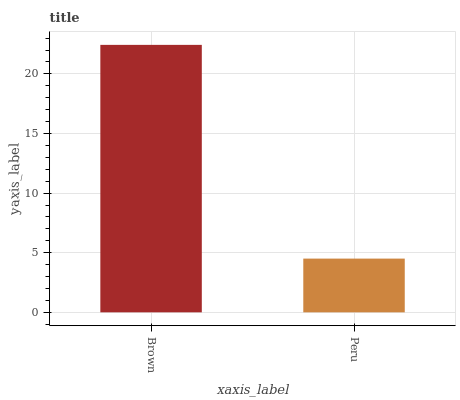Is Peru the minimum?
Answer yes or no. Yes. Is Brown the maximum?
Answer yes or no. Yes. Is Peru the maximum?
Answer yes or no. No. Is Brown greater than Peru?
Answer yes or no. Yes. Is Peru less than Brown?
Answer yes or no. Yes. Is Peru greater than Brown?
Answer yes or no. No. Is Brown less than Peru?
Answer yes or no. No. Is Brown the high median?
Answer yes or no. Yes. Is Peru the low median?
Answer yes or no. Yes. Is Peru the high median?
Answer yes or no. No. Is Brown the low median?
Answer yes or no. No. 